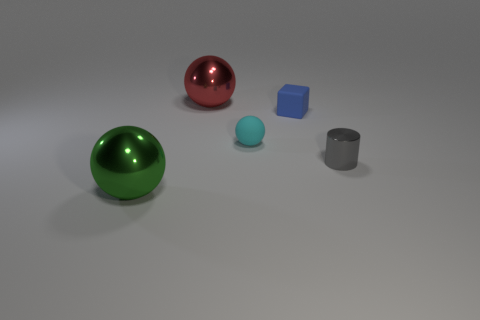Is there anything else that has the same shape as the blue rubber object?
Offer a terse response. No. What is the size of the metal thing that is both to the left of the small blue block and in front of the large red ball?
Ensure brevity in your answer.  Large. What color is the metal thing that is both in front of the block and left of the rubber cube?
Make the answer very short. Green. Is the number of red objects that are right of the gray thing less than the number of tiny cylinders in front of the small cyan ball?
Provide a succinct answer. Yes. What number of big green objects have the same shape as the tiny cyan object?
Your response must be concise. 1. There is a ball that is the same material as the tiny cube; what size is it?
Your response must be concise. Small. What is the color of the shiny sphere in front of the sphere that is on the right side of the large red ball?
Your answer should be very brief. Green. There is a red shiny object; is it the same shape as the shiny thing that is left of the red metallic sphere?
Provide a short and direct response. Yes. How many objects are the same size as the gray metallic cylinder?
Your response must be concise. 2. There is a green thing that is the same shape as the tiny cyan object; what is it made of?
Ensure brevity in your answer.  Metal. 